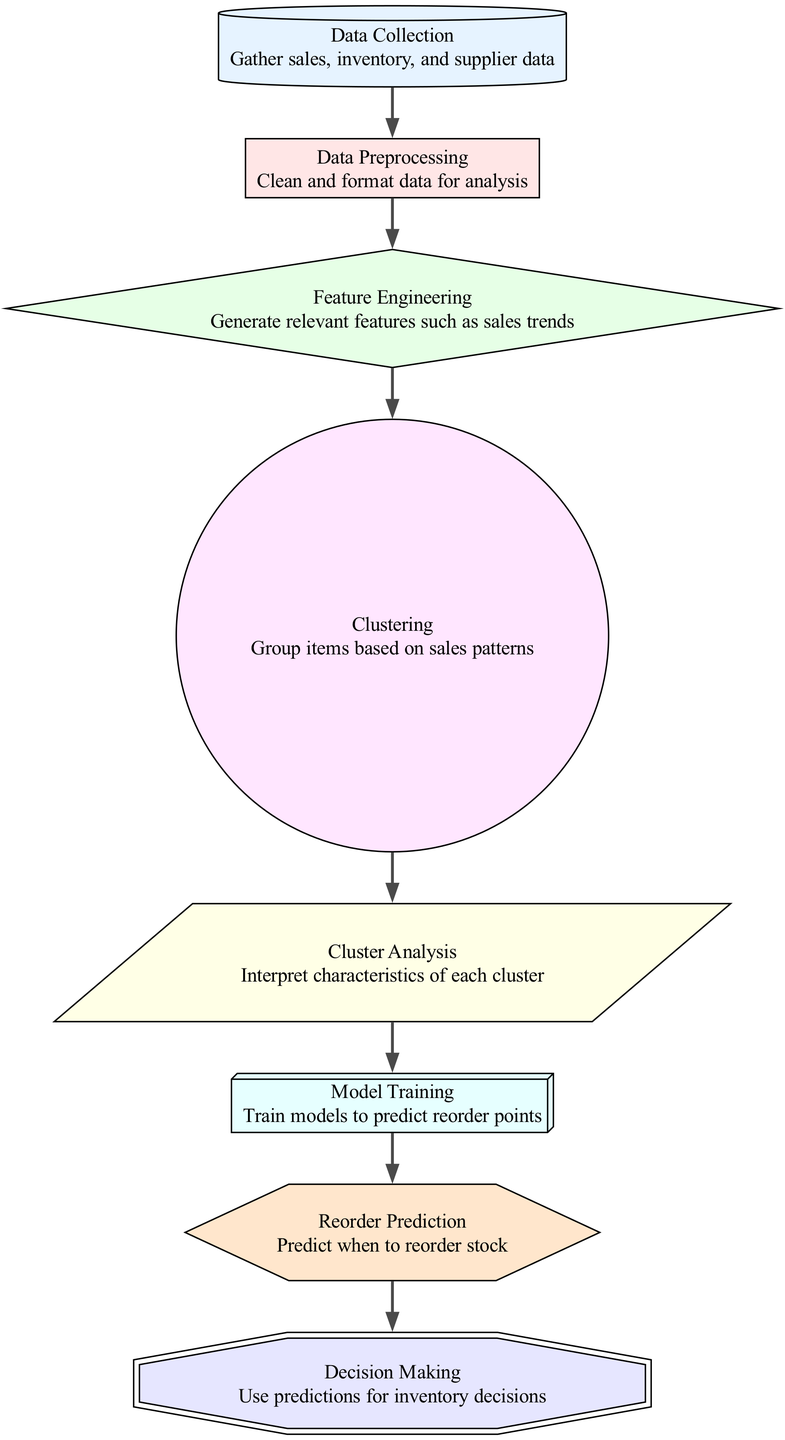What is the total number of nodes in this diagram? The diagram consists of eight distinct nodes, namely: Data Collection, Data Preprocessing, Feature Engineering, Clustering, Cluster Analysis, Model Training, Reorder Prediction, and Decision Making.
Answer: Eight Which node comes after Data Preprocessing? In the diagram's flow, the direct successor of Data Preprocessing is Feature Engineering, as indicated by the directed edge connecting these two nodes.
Answer: Feature Engineering How many edges are present in the diagram? Counting the edges, there are seven directed connections between nodes in the diagram, signifying the relationships and flow of information.
Answer: Seven What is the purpose of the Clustering node? The Clustering node is responsible for grouping items based on sales patterns, a key step in identifying which items have similar sales trends to optimize inventory management.
Answer: Group items based on sales patterns Which node leads directly to Decision Making? The node that leads directly to Decision Making is Reorder Prediction, as it provides the necessary information for inventory decisions by predicting when to reorder stock.
Answer: Reorder Prediction What type of node is Feature Engineering? Feature Engineering is depicted as a diamond-shaped node in the diagram, signifying that it plays a crucial role in the analysis process, specifically in generating relevant features like sales trends.
Answer: Diamond What does the Model Training node signify in the context of this diagram? The Model Training node signifies the process of training models to predict reorder points, which is essential for making informed decisions about stock management.
Answer: Train models to predict reorder points Which two nodes are connected by the edge from Clustering? The edge originating from Clustering connects to the next node, Cluster Analysis, indicating that clustering results need interpretation for further action in the workflow.
Answer: Cluster Analysis What is the final outcome of the flow in this machine learning diagram? The final outcome of the flow in the diagram is Decision Making, as all previous processes culminate in making informed inventory-related decisions based on the predictions generated.
Answer: Decision Making 